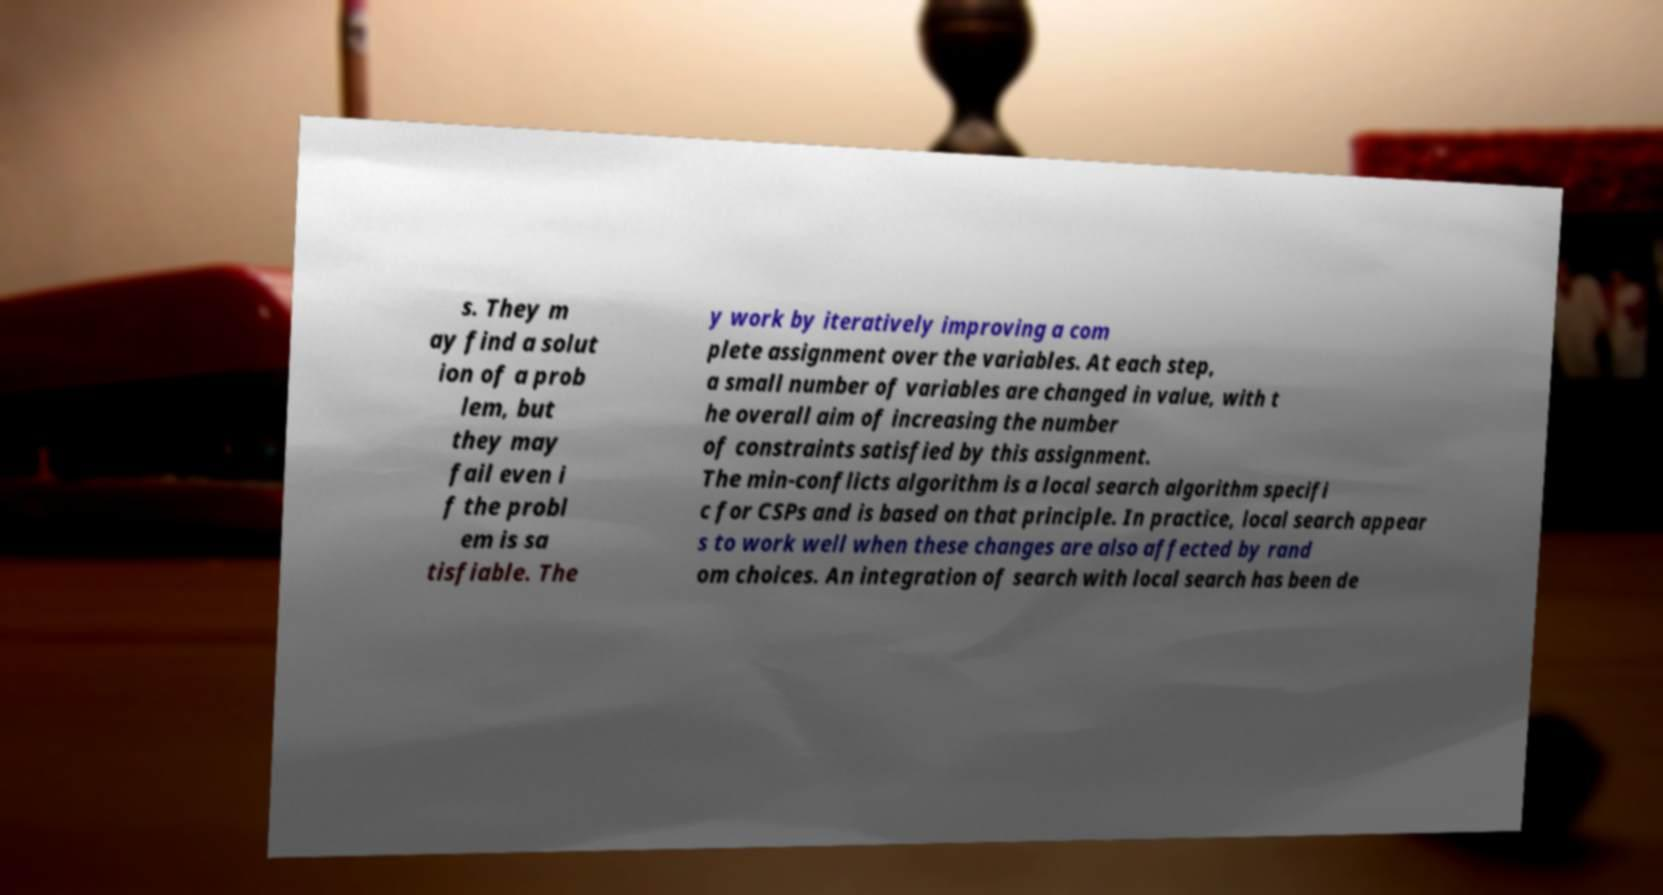Can you read and provide the text displayed in the image?This photo seems to have some interesting text. Can you extract and type it out for me? s. They m ay find a solut ion of a prob lem, but they may fail even i f the probl em is sa tisfiable. The y work by iteratively improving a com plete assignment over the variables. At each step, a small number of variables are changed in value, with t he overall aim of increasing the number of constraints satisfied by this assignment. The min-conflicts algorithm is a local search algorithm specifi c for CSPs and is based on that principle. In practice, local search appear s to work well when these changes are also affected by rand om choices. An integration of search with local search has been de 